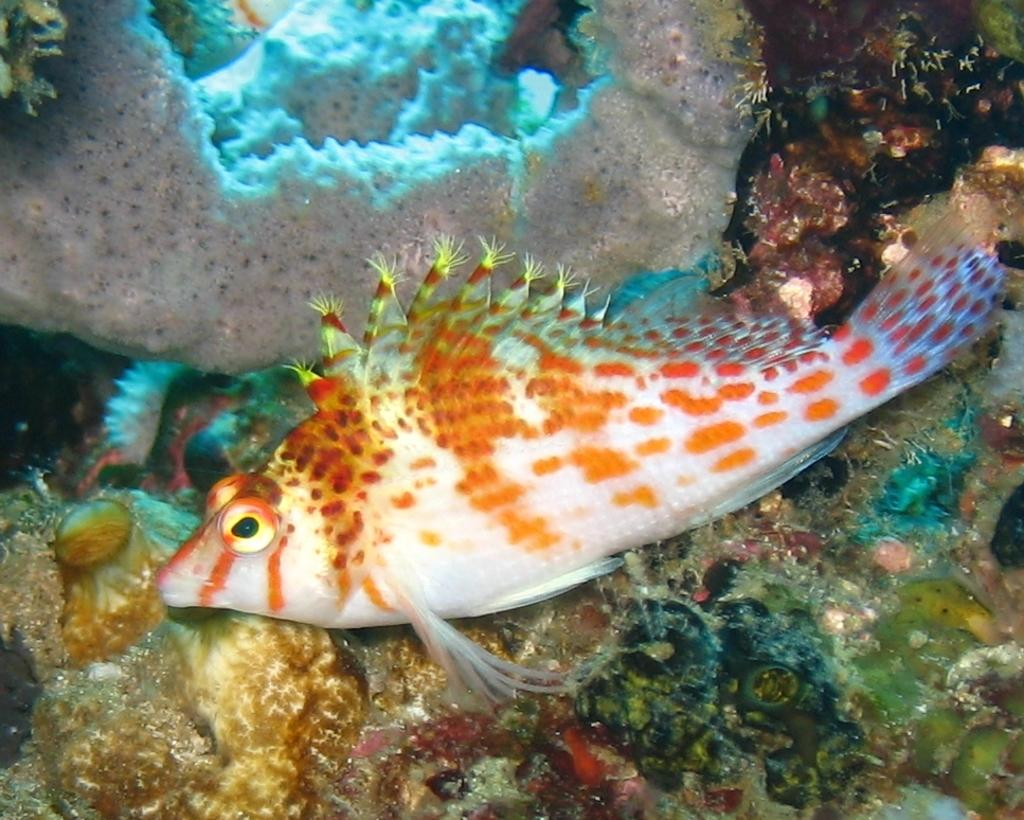Where was the image taken? The image was taken in an aquarium. What can be seen in the water in the image? There is a fish in the water. What colors does the fish have? The fish is orange and white in color. What can be seen in the background of the image? There are many coral reefs in the background. What type of machine can be seen in the image? There is no machine present in the image; it is a photograph taken in an aquarium featuring a fish and coral reefs. 